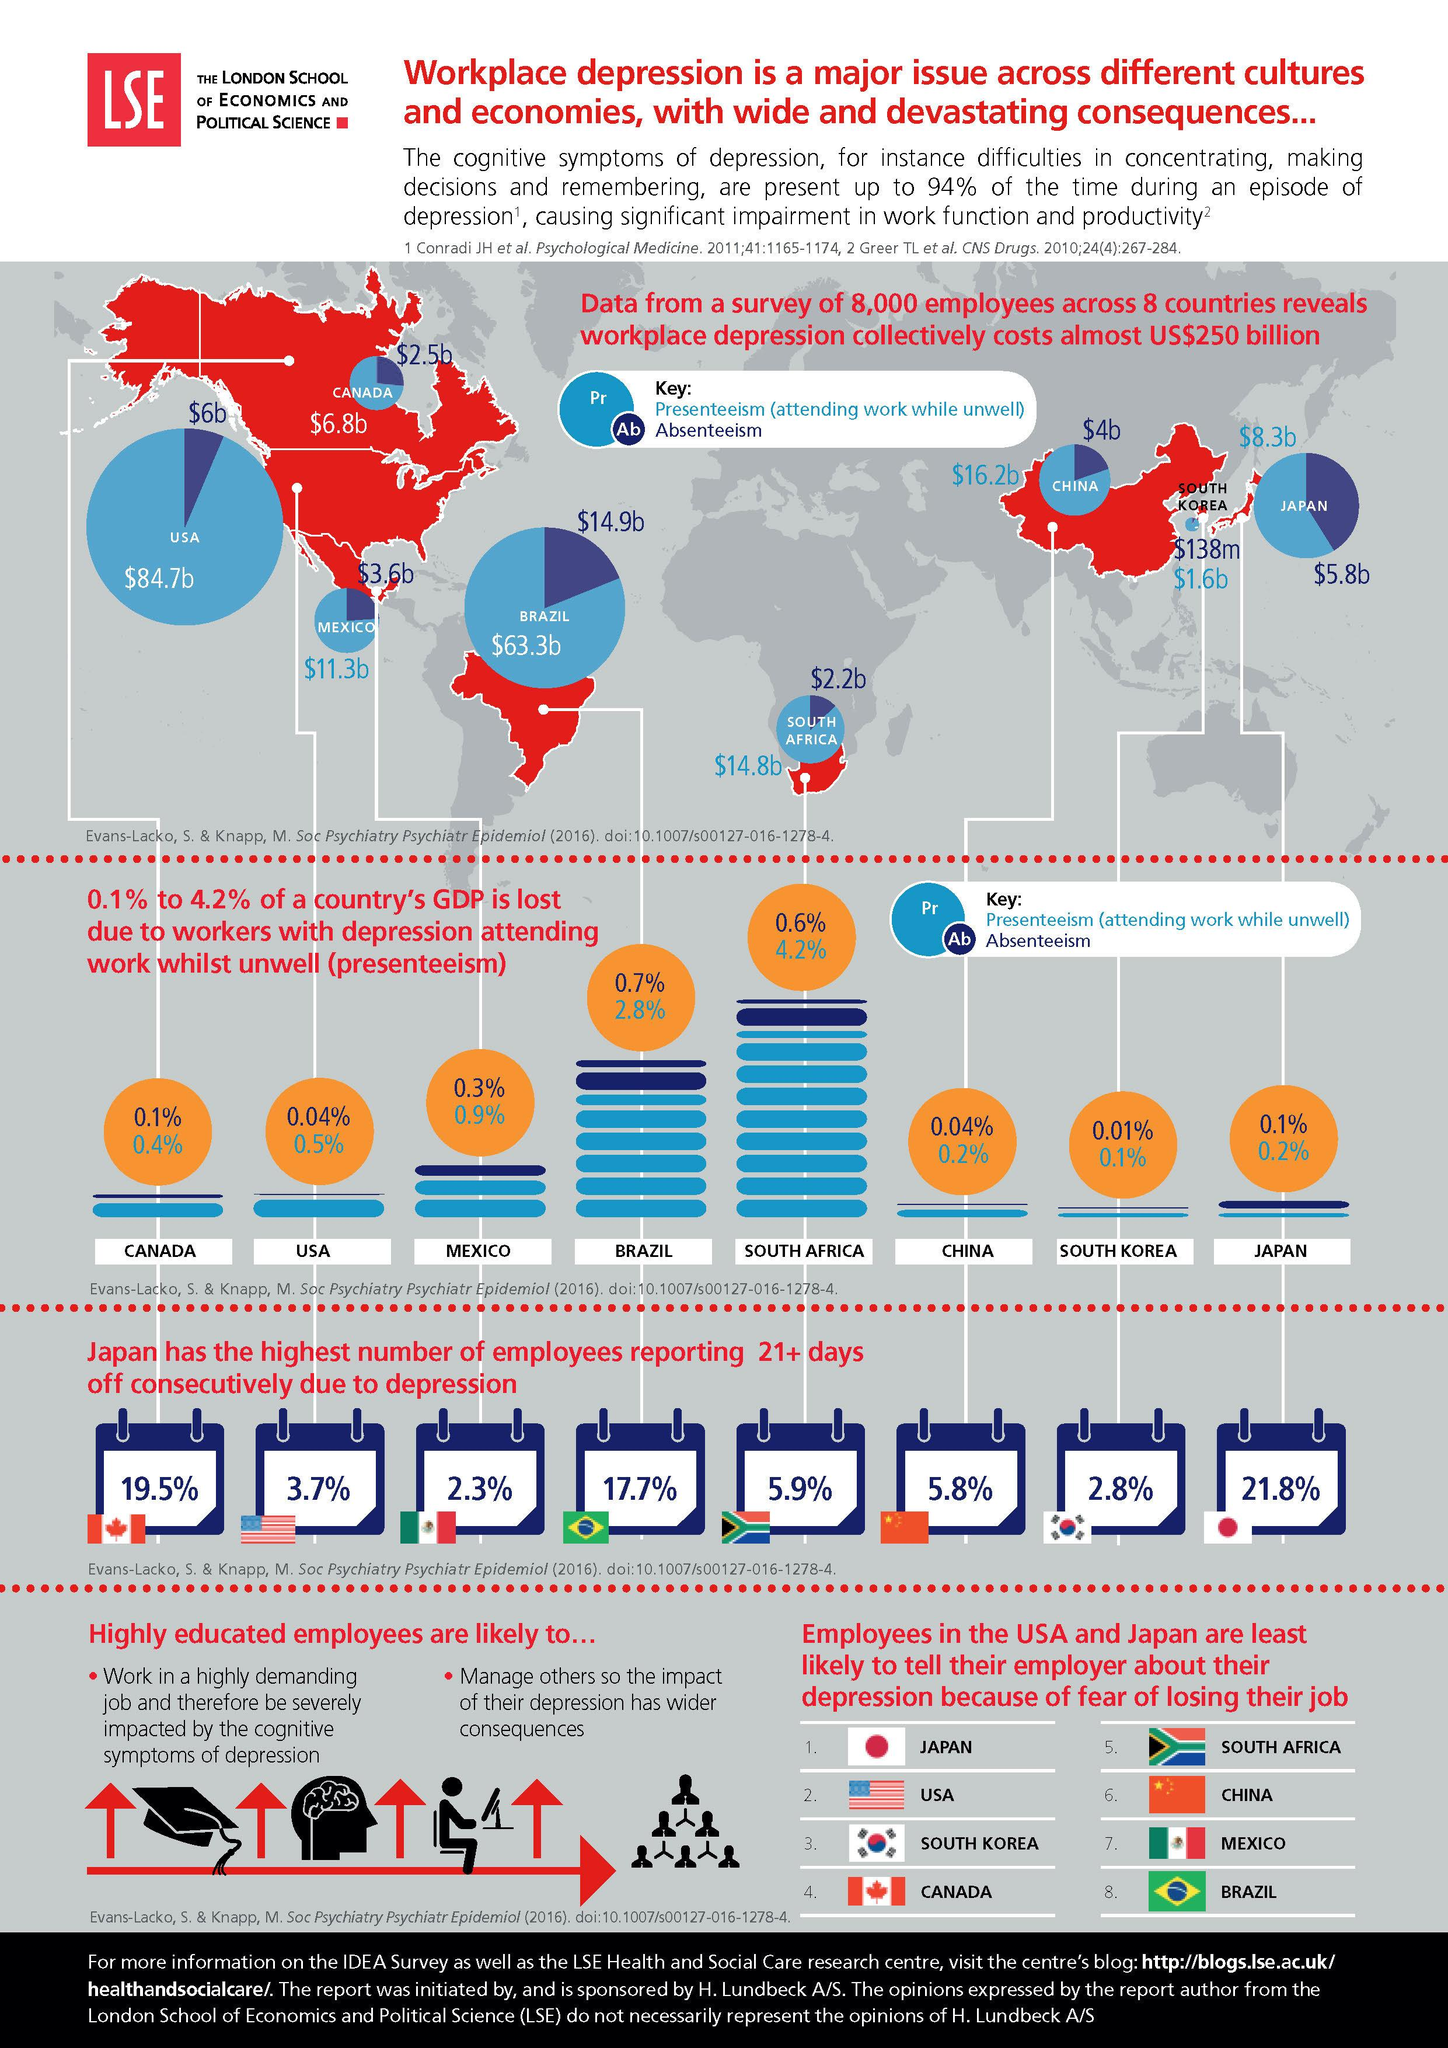Draw attention to some important aspects in this diagram. According to recent studies, South Korea has been found to incur the lowest costs due to absenteeism at the workplace when unwell. The country with the second highest percentage of employees taking offs due to depression is...19.5%. According to the data, Brazil experienced a loss of 0.7% of its Gross Domestic Product due to absenteeism. The loss of productivity due to presenteeism in China amounted to 0.2% of the country's GDP in a given year. The country that incurs the highest costs due to presenteeism at the workplace when unwell is the United States. 